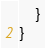<code> <loc_0><loc_0><loc_500><loc_500><_Kotlin_>    }
}
</code> 